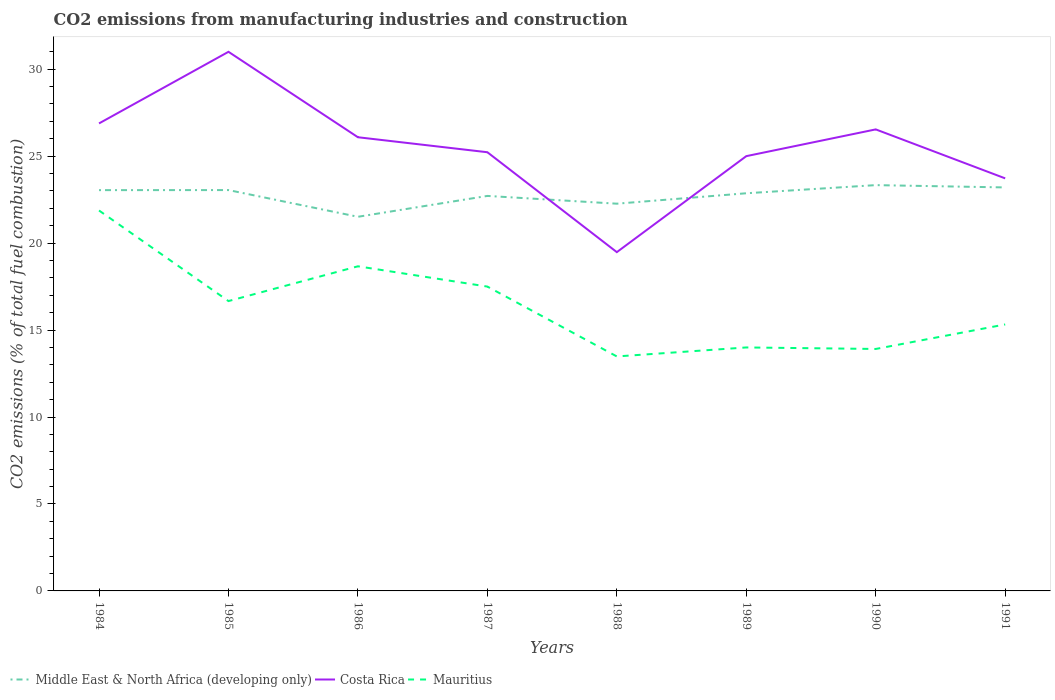Is the number of lines equal to the number of legend labels?
Offer a terse response. Yes. Across all years, what is the maximum amount of CO2 emitted in Middle East & North Africa (developing only)?
Your response must be concise. 21.51. What is the total amount of CO2 emitted in Mauritius in the graph?
Your answer should be compact. 4.75. What is the difference between the highest and the second highest amount of CO2 emitted in Mauritius?
Provide a succinct answer. 8.39. What is the difference between the highest and the lowest amount of CO2 emitted in Middle East & North Africa (developing only)?
Your answer should be very brief. 5. How many years are there in the graph?
Offer a very short reply. 8. What is the difference between two consecutive major ticks on the Y-axis?
Provide a succinct answer. 5. Are the values on the major ticks of Y-axis written in scientific E-notation?
Keep it short and to the point. No. Does the graph contain grids?
Make the answer very short. No. Where does the legend appear in the graph?
Provide a succinct answer. Bottom left. How many legend labels are there?
Give a very brief answer. 3. What is the title of the graph?
Ensure brevity in your answer.  CO2 emissions from manufacturing industries and construction. Does "Colombia" appear as one of the legend labels in the graph?
Your answer should be very brief. No. What is the label or title of the X-axis?
Ensure brevity in your answer.  Years. What is the label or title of the Y-axis?
Offer a very short reply. CO2 emissions (% of total fuel combustion). What is the CO2 emissions (% of total fuel combustion) of Middle East & North Africa (developing only) in 1984?
Offer a terse response. 23.05. What is the CO2 emissions (% of total fuel combustion) in Costa Rica in 1984?
Offer a very short reply. 26.88. What is the CO2 emissions (% of total fuel combustion) in Mauritius in 1984?
Provide a short and direct response. 21.88. What is the CO2 emissions (% of total fuel combustion) of Middle East & North Africa (developing only) in 1985?
Ensure brevity in your answer.  23.05. What is the CO2 emissions (% of total fuel combustion) in Costa Rica in 1985?
Offer a very short reply. 31. What is the CO2 emissions (% of total fuel combustion) in Mauritius in 1985?
Make the answer very short. 16.67. What is the CO2 emissions (% of total fuel combustion) in Middle East & North Africa (developing only) in 1986?
Give a very brief answer. 21.51. What is the CO2 emissions (% of total fuel combustion) in Costa Rica in 1986?
Your answer should be very brief. 26.09. What is the CO2 emissions (% of total fuel combustion) in Mauritius in 1986?
Ensure brevity in your answer.  18.67. What is the CO2 emissions (% of total fuel combustion) of Middle East & North Africa (developing only) in 1987?
Provide a short and direct response. 22.71. What is the CO2 emissions (% of total fuel combustion) in Costa Rica in 1987?
Provide a succinct answer. 25.23. What is the CO2 emissions (% of total fuel combustion) in Middle East & North Africa (developing only) in 1988?
Your response must be concise. 22.27. What is the CO2 emissions (% of total fuel combustion) in Costa Rica in 1988?
Your answer should be compact. 19.48. What is the CO2 emissions (% of total fuel combustion) in Mauritius in 1988?
Offer a very short reply. 13.48. What is the CO2 emissions (% of total fuel combustion) in Middle East & North Africa (developing only) in 1989?
Offer a very short reply. 22.87. What is the CO2 emissions (% of total fuel combustion) in Costa Rica in 1989?
Your answer should be very brief. 25. What is the CO2 emissions (% of total fuel combustion) in Mauritius in 1989?
Provide a short and direct response. 14. What is the CO2 emissions (% of total fuel combustion) in Middle East & North Africa (developing only) in 1990?
Your response must be concise. 23.33. What is the CO2 emissions (% of total fuel combustion) of Costa Rica in 1990?
Your response must be concise. 26.54. What is the CO2 emissions (% of total fuel combustion) of Mauritius in 1990?
Ensure brevity in your answer.  13.91. What is the CO2 emissions (% of total fuel combustion) in Middle East & North Africa (developing only) in 1991?
Your answer should be compact. 23.2. What is the CO2 emissions (% of total fuel combustion) in Costa Rica in 1991?
Your answer should be very brief. 23.72. What is the CO2 emissions (% of total fuel combustion) in Mauritius in 1991?
Your answer should be compact. 15.32. Across all years, what is the maximum CO2 emissions (% of total fuel combustion) in Middle East & North Africa (developing only)?
Your answer should be compact. 23.33. Across all years, what is the maximum CO2 emissions (% of total fuel combustion) of Mauritius?
Ensure brevity in your answer.  21.88. Across all years, what is the minimum CO2 emissions (% of total fuel combustion) in Middle East & North Africa (developing only)?
Your answer should be very brief. 21.51. Across all years, what is the minimum CO2 emissions (% of total fuel combustion) of Costa Rica?
Your response must be concise. 19.48. Across all years, what is the minimum CO2 emissions (% of total fuel combustion) of Mauritius?
Your answer should be compact. 13.48. What is the total CO2 emissions (% of total fuel combustion) of Middle East & North Africa (developing only) in the graph?
Your answer should be very brief. 181.99. What is the total CO2 emissions (% of total fuel combustion) of Costa Rica in the graph?
Provide a short and direct response. 203.94. What is the total CO2 emissions (% of total fuel combustion) of Mauritius in the graph?
Keep it short and to the point. 131.43. What is the difference between the CO2 emissions (% of total fuel combustion) of Middle East & North Africa (developing only) in 1984 and that in 1985?
Your answer should be compact. -0. What is the difference between the CO2 emissions (% of total fuel combustion) in Costa Rica in 1984 and that in 1985?
Keep it short and to the point. -4.12. What is the difference between the CO2 emissions (% of total fuel combustion) in Mauritius in 1984 and that in 1985?
Give a very brief answer. 5.21. What is the difference between the CO2 emissions (% of total fuel combustion) in Middle East & North Africa (developing only) in 1984 and that in 1986?
Ensure brevity in your answer.  1.53. What is the difference between the CO2 emissions (% of total fuel combustion) of Costa Rica in 1984 and that in 1986?
Keep it short and to the point. 0.79. What is the difference between the CO2 emissions (% of total fuel combustion) of Mauritius in 1984 and that in 1986?
Your answer should be compact. 3.21. What is the difference between the CO2 emissions (% of total fuel combustion) of Middle East & North Africa (developing only) in 1984 and that in 1987?
Your answer should be very brief. 0.33. What is the difference between the CO2 emissions (% of total fuel combustion) of Costa Rica in 1984 and that in 1987?
Provide a succinct answer. 1.66. What is the difference between the CO2 emissions (% of total fuel combustion) of Mauritius in 1984 and that in 1987?
Offer a very short reply. 4.38. What is the difference between the CO2 emissions (% of total fuel combustion) of Middle East & North Africa (developing only) in 1984 and that in 1988?
Your answer should be compact. 0.78. What is the difference between the CO2 emissions (% of total fuel combustion) in Costa Rica in 1984 and that in 1988?
Give a very brief answer. 7.4. What is the difference between the CO2 emissions (% of total fuel combustion) of Mauritius in 1984 and that in 1988?
Ensure brevity in your answer.  8.39. What is the difference between the CO2 emissions (% of total fuel combustion) of Middle East & North Africa (developing only) in 1984 and that in 1989?
Your response must be concise. 0.18. What is the difference between the CO2 emissions (% of total fuel combustion) in Costa Rica in 1984 and that in 1989?
Your response must be concise. 1.88. What is the difference between the CO2 emissions (% of total fuel combustion) of Mauritius in 1984 and that in 1989?
Offer a very short reply. 7.88. What is the difference between the CO2 emissions (% of total fuel combustion) in Middle East & North Africa (developing only) in 1984 and that in 1990?
Give a very brief answer. -0.29. What is the difference between the CO2 emissions (% of total fuel combustion) of Costa Rica in 1984 and that in 1990?
Ensure brevity in your answer.  0.34. What is the difference between the CO2 emissions (% of total fuel combustion) in Mauritius in 1984 and that in 1990?
Ensure brevity in your answer.  7.96. What is the difference between the CO2 emissions (% of total fuel combustion) of Middle East & North Africa (developing only) in 1984 and that in 1991?
Your response must be concise. -0.16. What is the difference between the CO2 emissions (% of total fuel combustion) in Costa Rica in 1984 and that in 1991?
Provide a succinct answer. 3.16. What is the difference between the CO2 emissions (% of total fuel combustion) of Mauritius in 1984 and that in 1991?
Make the answer very short. 6.55. What is the difference between the CO2 emissions (% of total fuel combustion) in Middle East & North Africa (developing only) in 1985 and that in 1986?
Offer a terse response. 1.54. What is the difference between the CO2 emissions (% of total fuel combustion) in Costa Rica in 1985 and that in 1986?
Your answer should be compact. 4.91. What is the difference between the CO2 emissions (% of total fuel combustion) in Middle East & North Africa (developing only) in 1985 and that in 1987?
Ensure brevity in your answer.  0.34. What is the difference between the CO2 emissions (% of total fuel combustion) in Costa Rica in 1985 and that in 1987?
Ensure brevity in your answer.  5.77. What is the difference between the CO2 emissions (% of total fuel combustion) in Middle East & North Africa (developing only) in 1985 and that in 1988?
Give a very brief answer. 0.78. What is the difference between the CO2 emissions (% of total fuel combustion) in Costa Rica in 1985 and that in 1988?
Your answer should be compact. 11.52. What is the difference between the CO2 emissions (% of total fuel combustion) in Mauritius in 1985 and that in 1988?
Provide a short and direct response. 3.18. What is the difference between the CO2 emissions (% of total fuel combustion) in Middle East & North Africa (developing only) in 1985 and that in 1989?
Ensure brevity in your answer.  0.18. What is the difference between the CO2 emissions (% of total fuel combustion) in Mauritius in 1985 and that in 1989?
Offer a very short reply. 2.67. What is the difference between the CO2 emissions (% of total fuel combustion) in Middle East & North Africa (developing only) in 1985 and that in 1990?
Make the answer very short. -0.28. What is the difference between the CO2 emissions (% of total fuel combustion) of Costa Rica in 1985 and that in 1990?
Offer a terse response. 4.46. What is the difference between the CO2 emissions (% of total fuel combustion) in Mauritius in 1985 and that in 1990?
Offer a terse response. 2.75. What is the difference between the CO2 emissions (% of total fuel combustion) in Middle East & North Africa (developing only) in 1985 and that in 1991?
Provide a short and direct response. -0.15. What is the difference between the CO2 emissions (% of total fuel combustion) in Costa Rica in 1985 and that in 1991?
Make the answer very short. 7.28. What is the difference between the CO2 emissions (% of total fuel combustion) of Mauritius in 1985 and that in 1991?
Your answer should be very brief. 1.34. What is the difference between the CO2 emissions (% of total fuel combustion) of Middle East & North Africa (developing only) in 1986 and that in 1987?
Offer a very short reply. -1.2. What is the difference between the CO2 emissions (% of total fuel combustion) in Costa Rica in 1986 and that in 1987?
Provide a short and direct response. 0.86. What is the difference between the CO2 emissions (% of total fuel combustion) in Mauritius in 1986 and that in 1987?
Ensure brevity in your answer.  1.17. What is the difference between the CO2 emissions (% of total fuel combustion) in Middle East & North Africa (developing only) in 1986 and that in 1988?
Ensure brevity in your answer.  -0.75. What is the difference between the CO2 emissions (% of total fuel combustion) of Costa Rica in 1986 and that in 1988?
Offer a terse response. 6.61. What is the difference between the CO2 emissions (% of total fuel combustion) of Mauritius in 1986 and that in 1988?
Your answer should be compact. 5.18. What is the difference between the CO2 emissions (% of total fuel combustion) of Middle East & North Africa (developing only) in 1986 and that in 1989?
Offer a terse response. -1.35. What is the difference between the CO2 emissions (% of total fuel combustion) in Costa Rica in 1986 and that in 1989?
Your response must be concise. 1.09. What is the difference between the CO2 emissions (% of total fuel combustion) of Mauritius in 1986 and that in 1989?
Give a very brief answer. 4.67. What is the difference between the CO2 emissions (% of total fuel combustion) of Middle East & North Africa (developing only) in 1986 and that in 1990?
Provide a short and direct response. -1.82. What is the difference between the CO2 emissions (% of total fuel combustion) in Costa Rica in 1986 and that in 1990?
Provide a short and direct response. -0.45. What is the difference between the CO2 emissions (% of total fuel combustion) of Mauritius in 1986 and that in 1990?
Make the answer very short. 4.75. What is the difference between the CO2 emissions (% of total fuel combustion) in Middle East & North Africa (developing only) in 1986 and that in 1991?
Your answer should be compact. -1.69. What is the difference between the CO2 emissions (% of total fuel combustion) of Costa Rica in 1986 and that in 1991?
Make the answer very short. 2.36. What is the difference between the CO2 emissions (% of total fuel combustion) in Mauritius in 1986 and that in 1991?
Your answer should be compact. 3.34. What is the difference between the CO2 emissions (% of total fuel combustion) in Middle East & North Africa (developing only) in 1987 and that in 1988?
Your response must be concise. 0.45. What is the difference between the CO2 emissions (% of total fuel combustion) in Costa Rica in 1987 and that in 1988?
Keep it short and to the point. 5.74. What is the difference between the CO2 emissions (% of total fuel combustion) in Mauritius in 1987 and that in 1988?
Your answer should be very brief. 4.02. What is the difference between the CO2 emissions (% of total fuel combustion) of Middle East & North Africa (developing only) in 1987 and that in 1989?
Ensure brevity in your answer.  -0.15. What is the difference between the CO2 emissions (% of total fuel combustion) in Costa Rica in 1987 and that in 1989?
Offer a very short reply. 0.23. What is the difference between the CO2 emissions (% of total fuel combustion) in Mauritius in 1987 and that in 1989?
Your answer should be very brief. 3.5. What is the difference between the CO2 emissions (% of total fuel combustion) in Middle East & North Africa (developing only) in 1987 and that in 1990?
Give a very brief answer. -0.62. What is the difference between the CO2 emissions (% of total fuel combustion) in Costa Rica in 1987 and that in 1990?
Offer a very short reply. -1.31. What is the difference between the CO2 emissions (% of total fuel combustion) of Mauritius in 1987 and that in 1990?
Ensure brevity in your answer.  3.59. What is the difference between the CO2 emissions (% of total fuel combustion) in Middle East & North Africa (developing only) in 1987 and that in 1991?
Your answer should be compact. -0.49. What is the difference between the CO2 emissions (% of total fuel combustion) in Costa Rica in 1987 and that in 1991?
Keep it short and to the point. 1.5. What is the difference between the CO2 emissions (% of total fuel combustion) of Mauritius in 1987 and that in 1991?
Give a very brief answer. 2.18. What is the difference between the CO2 emissions (% of total fuel combustion) in Middle East & North Africa (developing only) in 1988 and that in 1989?
Give a very brief answer. -0.6. What is the difference between the CO2 emissions (% of total fuel combustion) of Costa Rica in 1988 and that in 1989?
Provide a short and direct response. -5.52. What is the difference between the CO2 emissions (% of total fuel combustion) of Mauritius in 1988 and that in 1989?
Make the answer very short. -0.52. What is the difference between the CO2 emissions (% of total fuel combustion) of Middle East & North Africa (developing only) in 1988 and that in 1990?
Offer a terse response. -1.07. What is the difference between the CO2 emissions (% of total fuel combustion) of Costa Rica in 1988 and that in 1990?
Ensure brevity in your answer.  -7.06. What is the difference between the CO2 emissions (% of total fuel combustion) in Mauritius in 1988 and that in 1990?
Offer a terse response. -0.43. What is the difference between the CO2 emissions (% of total fuel combustion) in Middle East & North Africa (developing only) in 1988 and that in 1991?
Make the answer very short. -0.94. What is the difference between the CO2 emissions (% of total fuel combustion) in Costa Rica in 1988 and that in 1991?
Your answer should be very brief. -4.24. What is the difference between the CO2 emissions (% of total fuel combustion) of Mauritius in 1988 and that in 1991?
Give a very brief answer. -1.84. What is the difference between the CO2 emissions (% of total fuel combustion) in Middle East & North Africa (developing only) in 1989 and that in 1990?
Your response must be concise. -0.47. What is the difference between the CO2 emissions (% of total fuel combustion) in Costa Rica in 1989 and that in 1990?
Give a very brief answer. -1.54. What is the difference between the CO2 emissions (% of total fuel combustion) in Mauritius in 1989 and that in 1990?
Make the answer very short. 0.09. What is the difference between the CO2 emissions (% of total fuel combustion) in Middle East & North Africa (developing only) in 1989 and that in 1991?
Your answer should be very brief. -0.34. What is the difference between the CO2 emissions (% of total fuel combustion) of Costa Rica in 1989 and that in 1991?
Your answer should be compact. 1.28. What is the difference between the CO2 emissions (% of total fuel combustion) of Mauritius in 1989 and that in 1991?
Offer a very short reply. -1.32. What is the difference between the CO2 emissions (% of total fuel combustion) of Middle East & North Africa (developing only) in 1990 and that in 1991?
Make the answer very short. 0.13. What is the difference between the CO2 emissions (% of total fuel combustion) of Costa Rica in 1990 and that in 1991?
Your answer should be very brief. 2.82. What is the difference between the CO2 emissions (% of total fuel combustion) in Mauritius in 1990 and that in 1991?
Provide a succinct answer. -1.41. What is the difference between the CO2 emissions (% of total fuel combustion) in Middle East & North Africa (developing only) in 1984 and the CO2 emissions (% of total fuel combustion) in Costa Rica in 1985?
Give a very brief answer. -7.95. What is the difference between the CO2 emissions (% of total fuel combustion) in Middle East & North Africa (developing only) in 1984 and the CO2 emissions (% of total fuel combustion) in Mauritius in 1985?
Offer a terse response. 6.38. What is the difference between the CO2 emissions (% of total fuel combustion) in Costa Rica in 1984 and the CO2 emissions (% of total fuel combustion) in Mauritius in 1985?
Your answer should be compact. 10.22. What is the difference between the CO2 emissions (% of total fuel combustion) in Middle East & North Africa (developing only) in 1984 and the CO2 emissions (% of total fuel combustion) in Costa Rica in 1986?
Your response must be concise. -3.04. What is the difference between the CO2 emissions (% of total fuel combustion) of Middle East & North Africa (developing only) in 1984 and the CO2 emissions (% of total fuel combustion) of Mauritius in 1986?
Your answer should be compact. 4.38. What is the difference between the CO2 emissions (% of total fuel combustion) in Costa Rica in 1984 and the CO2 emissions (% of total fuel combustion) in Mauritius in 1986?
Your answer should be very brief. 8.22. What is the difference between the CO2 emissions (% of total fuel combustion) of Middle East & North Africa (developing only) in 1984 and the CO2 emissions (% of total fuel combustion) of Costa Rica in 1987?
Your response must be concise. -2.18. What is the difference between the CO2 emissions (% of total fuel combustion) in Middle East & North Africa (developing only) in 1984 and the CO2 emissions (% of total fuel combustion) in Mauritius in 1987?
Make the answer very short. 5.55. What is the difference between the CO2 emissions (% of total fuel combustion) in Costa Rica in 1984 and the CO2 emissions (% of total fuel combustion) in Mauritius in 1987?
Provide a succinct answer. 9.38. What is the difference between the CO2 emissions (% of total fuel combustion) in Middle East & North Africa (developing only) in 1984 and the CO2 emissions (% of total fuel combustion) in Costa Rica in 1988?
Keep it short and to the point. 3.57. What is the difference between the CO2 emissions (% of total fuel combustion) of Middle East & North Africa (developing only) in 1984 and the CO2 emissions (% of total fuel combustion) of Mauritius in 1988?
Make the answer very short. 9.56. What is the difference between the CO2 emissions (% of total fuel combustion) of Costa Rica in 1984 and the CO2 emissions (% of total fuel combustion) of Mauritius in 1988?
Ensure brevity in your answer.  13.4. What is the difference between the CO2 emissions (% of total fuel combustion) in Middle East & North Africa (developing only) in 1984 and the CO2 emissions (% of total fuel combustion) in Costa Rica in 1989?
Provide a succinct answer. -1.95. What is the difference between the CO2 emissions (% of total fuel combustion) of Middle East & North Africa (developing only) in 1984 and the CO2 emissions (% of total fuel combustion) of Mauritius in 1989?
Your answer should be compact. 9.05. What is the difference between the CO2 emissions (% of total fuel combustion) of Costa Rica in 1984 and the CO2 emissions (% of total fuel combustion) of Mauritius in 1989?
Make the answer very short. 12.88. What is the difference between the CO2 emissions (% of total fuel combustion) in Middle East & North Africa (developing only) in 1984 and the CO2 emissions (% of total fuel combustion) in Costa Rica in 1990?
Offer a terse response. -3.49. What is the difference between the CO2 emissions (% of total fuel combustion) of Middle East & North Africa (developing only) in 1984 and the CO2 emissions (% of total fuel combustion) of Mauritius in 1990?
Your response must be concise. 9.13. What is the difference between the CO2 emissions (% of total fuel combustion) in Costa Rica in 1984 and the CO2 emissions (% of total fuel combustion) in Mauritius in 1990?
Keep it short and to the point. 12.97. What is the difference between the CO2 emissions (% of total fuel combustion) in Middle East & North Africa (developing only) in 1984 and the CO2 emissions (% of total fuel combustion) in Costa Rica in 1991?
Offer a very short reply. -0.68. What is the difference between the CO2 emissions (% of total fuel combustion) of Middle East & North Africa (developing only) in 1984 and the CO2 emissions (% of total fuel combustion) of Mauritius in 1991?
Offer a very short reply. 7.72. What is the difference between the CO2 emissions (% of total fuel combustion) in Costa Rica in 1984 and the CO2 emissions (% of total fuel combustion) in Mauritius in 1991?
Keep it short and to the point. 11.56. What is the difference between the CO2 emissions (% of total fuel combustion) of Middle East & North Africa (developing only) in 1985 and the CO2 emissions (% of total fuel combustion) of Costa Rica in 1986?
Give a very brief answer. -3.04. What is the difference between the CO2 emissions (% of total fuel combustion) in Middle East & North Africa (developing only) in 1985 and the CO2 emissions (% of total fuel combustion) in Mauritius in 1986?
Make the answer very short. 4.38. What is the difference between the CO2 emissions (% of total fuel combustion) in Costa Rica in 1985 and the CO2 emissions (% of total fuel combustion) in Mauritius in 1986?
Make the answer very short. 12.33. What is the difference between the CO2 emissions (% of total fuel combustion) in Middle East & North Africa (developing only) in 1985 and the CO2 emissions (% of total fuel combustion) in Costa Rica in 1987?
Give a very brief answer. -2.18. What is the difference between the CO2 emissions (% of total fuel combustion) of Middle East & North Africa (developing only) in 1985 and the CO2 emissions (% of total fuel combustion) of Mauritius in 1987?
Offer a terse response. 5.55. What is the difference between the CO2 emissions (% of total fuel combustion) of Middle East & North Africa (developing only) in 1985 and the CO2 emissions (% of total fuel combustion) of Costa Rica in 1988?
Offer a terse response. 3.57. What is the difference between the CO2 emissions (% of total fuel combustion) in Middle East & North Africa (developing only) in 1985 and the CO2 emissions (% of total fuel combustion) in Mauritius in 1988?
Keep it short and to the point. 9.57. What is the difference between the CO2 emissions (% of total fuel combustion) of Costa Rica in 1985 and the CO2 emissions (% of total fuel combustion) of Mauritius in 1988?
Your answer should be compact. 17.52. What is the difference between the CO2 emissions (% of total fuel combustion) of Middle East & North Africa (developing only) in 1985 and the CO2 emissions (% of total fuel combustion) of Costa Rica in 1989?
Give a very brief answer. -1.95. What is the difference between the CO2 emissions (% of total fuel combustion) of Middle East & North Africa (developing only) in 1985 and the CO2 emissions (% of total fuel combustion) of Mauritius in 1989?
Make the answer very short. 9.05. What is the difference between the CO2 emissions (% of total fuel combustion) in Middle East & North Africa (developing only) in 1985 and the CO2 emissions (% of total fuel combustion) in Costa Rica in 1990?
Provide a short and direct response. -3.49. What is the difference between the CO2 emissions (% of total fuel combustion) in Middle East & North Africa (developing only) in 1985 and the CO2 emissions (% of total fuel combustion) in Mauritius in 1990?
Offer a terse response. 9.14. What is the difference between the CO2 emissions (% of total fuel combustion) in Costa Rica in 1985 and the CO2 emissions (% of total fuel combustion) in Mauritius in 1990?
Your answer should be very brief. 17.09. What is the difference between the CO2 emissions (% of total fuel combustion) of Middle East & North Africa (developing only) in 1985 and the CO2 emissions (% of total fuel combustion) of Costa Rica in 1991?
Keep it short and to the point. -0.67. What is the difference between the CO2 emissions (% of total fuel combustion) in Middle East & North Africa (developing only) in 1985 and the CO2 emissions (% of total fuel combustion) in Mauritius in 1991?
Ensure brevity in your answer.  7.73. What is the difference between the CO2 emissions (% of total fuel combustion) in Costa Rica in 1985 and the CO2 emissions (% of total fuel combustion) in Mauritius in 1991?
Your answer should be compact. 15.68. What is the difference between the CO2 emissions (% of total fuel combustion) in Middle East & North Africa (developing only) in 1986 and the CO2 emissions (% of total fuel combustion) in Costa Rica in 1987?
Offer a very short reply. -3.71. What is the difference between the CO2 emissions (% of total fuel combustion) of Middle East & North Africa (developing only) in 1986 and the CO2 emissions (% of total fuel combustion) of Mauritius in 1987?
Keep it short and to the point. 4.01. What is the difference between the CO2 emissions (% of total fuel combustion) in Costa Rica in 1986 and the CO2 emissions (% of total fuel combustion) in Mauritius in 1987?
Ensure brevity in your answer.  8.59. What is the difference between the CO2 emissions (% of total fuel combustion) of Middle East & North Africa (developing only) in 1986 and the CO2 emissions (% of total fuel combustion) of Costa Rica in 1988?
Provide a short and direct response. 2.03. What is the difference between the CO2 emissions (% of total fuel combustion) in Middle East & North Africa (developing only) in 1986 and the CO2 emissions (% of total fuel combustion) in Mauritius in 1988?
Ensure brevity in your answer.  8.03. What is the difference between the CO2 emissions (% of total fuel combustion) in Costa Rica in 1986 and the CO2 emissions (% of total fuel combustion) in Mauritius in 1988?
Provide a succinct answer. 12.6. What is the difference between the CO2 emissions (% of total fuel combustion) in Middle East & North Africa (developing only) in 1986 and the CO2 emissions (% of total fuel combustion) in Costa Rica in 1989?
Ensure brevity in your answer.  -3.49. What is the difference between the CO2 emissions (% of total fuel combustion) of Middle East & North Africa (developing only) in 1986 and the CO2 emissions (% of total fuel combustion) of Mauritius in 1989?
Offer a terse response. 7.51. What is the difference between the CO2 emissions (% of total fuel combustion) of Costa Rica in 1986 and the CO2 emissions (% of total fuel combustion) of Mauritius in 1989?
Provide a short and direct response. 12.09. What is the difference between the CO2 emissions (% of total fuel combustion) in Middle East & North Africa (developing only) in 1986 and the CO2 emissions (% of total fuel combustion) in Costa Rica in 1990?
Make the answer very short. -5.02. What is the difference between the CO2 emissions (% of total fuel combustion) of Middle East & North Africa (developing only) in 1986 and the CO2 emissions (% of total fuel combustion) of Mauritius in 1990?
Ensure brevity in your answer.  7.6. What is the difference between the CO2 emissions (% of total fuel combustion) in Costa Rica in 1986 and the CO2 emissions (% of total fuel combustion) in Mauritius in 1990?
Your response must be concise. 12.17. What is the difference between the CO2 emissions (% of total fuel combustion) in Middle East & North Africa (developing only) in 1986 and the CO2 emissions (% of total fuel combustion) in Costa Rica in 1991?
Your answer should be very brief. -2.21. What is the difference between the CO2 emissions (% of total fuel combustion) of Middle East & North Africa (developing only) in 1986 and the CO2 emissions (% of total fuel combustion) of Mauritius in 1991?
Keep it short and to the point. 6.19. What is the difference between the CO2 emissions (% of total fuel combustion) in Costa Rica in 1986 and the CO2 emissions (% of total fuel combustion) in Mauritius in 1991?
Ensure brevity in your answer.  10.76. What is the difference between the CO2 emissions (% of total fuel combustion) of Middle East & North Africa (developing only) in 1987 and the CO2 emissions (% of total fuel combustion) of Costa Rica in 1988?
Provide a short and direct response. 3.23. What is the difference between the CO2 emissions (% of total fuel combustion) in Middle East & North Africa (developing only) in 1987 and the CO2 emissions (% of total fuel combustion) in Mauritius in 1988?
Provide a succinct answer. 9.23. What is the difference between the CO2 emissions (% of total fuel combustion) in Costa Rica in 1987 and the CO2 emissions (% of total fuel combustion) in Mauritius in 1988?
Make the answer very short. 11.74. What is the difference between the CO2 emissions (% of total fuel combustion) in Middle East & North Africa (developing only) in 1987 and the CO2 emissions (% of total fuel combustion) in Costa Rica in 1989?
Keep it short and to the point. -2.29. What is the difference between the CO2 emissions (% of total fuel combustion) in Middle East & North Africa (developing only) in 1987 and the CO2 emissions (% of total fuel combustion) in Mauritius in 1989?
Provide a short and direct response. 8.71. What is the difference between the CO2 emissions (% of total fuel combustion) in Costa Rica in 1987 and the CO2 emissions (% of total fuel combustion) in Mauritius in 1989?
Offer a very short reply. 11.23. What is the difference between the CO2 emissions (% of total fuel combustion) of Middle East & North Africa (developing only) in 1987 and the CO2 emissions (% of total fuel combustion) of Costa Rica in 1990?
Make the answer very short. -3.83. What is the difference between the CO2 emissions (% of total fuel combustion) of Middle East & North Africa (developing only) in 1987 and the CO2 emissions (% of total fuel combustion) of Mauritius in 1990?
Ensure brevity in your answer.  8.8. What is the difference between the CO2 emissions (% of total fuel combustion) in Costa Rica in 1987 and the CO2 emissions (% of total fuel combustion) in Mauritius in 1990?
Keep it short and to the point. 11.31. What is the difference between the CO2 emissions (% of total fuel combustion) of Middle East & North Africa (developing only) in 1987 and the CO2 emissions (% of total fuel combustion) of Costa Rica in 1991?
Keep it short and to the point. -1.01. What is the difference between the CO2 emissions (% of total fuel combustion) of Middle East & North Africa (developing only) in 1987 and the CO2 emissions (% of total fuel combustion) of Mauritius in 1991?
Your answer should be compact. 7.39. What is the difference between the CO2 emissions (% of total fuel combustion) in Costa Rica in 1987 and the CO2 emissions (% of total fuel combustion) in Mauritius in 1991?
Ensure brevity in your answer.  9.9. What is the difference between the CO2 emissions (% of total fuel combustion) in Middle East & North Africa (developing only) in 1988 and the CO2 emissions (% of total fuel combustion) in Costa Rica in 1989?
Your answer should be compact. -2.73. What is the difference between the CO2 emissions (% of total fuel combustion) of Middle East & North Africa (developing only) in 1988 and the CO2 emissions (% of total fuel combustion) of Mauritius in 1989?
Keep it short and to the point. 8.27. What is the difference between the CO2 emissions (% of total fuel combustion) of Costa Rica in 1988 and the CO2 emissions (% of total fuel combustion) of Mauritius in 1989?
Offer a very short reply. 5.48. What is the difference between the CO2 emissions (% of total fuel combustion) of Middle East & North Africa (developing only) in 1988 and the CO2 emissions (% of total fuel combustion) of Costa Rica in 1990?
Your answer should be compact. -4.27. What is the difference between the CO2 emissions (% of total fuel combustion) of Middle East & North Africa (developing only) in 1988 and the CO2 emissions (% of total fuel combustion) of Mauritius in 1990?
Your response must be concise. 8.35. What is the difference between the CO2 emissions (% of total fuel combustion) of Costa Rica in 1988 and the CO2 emissions (% of total fuel combustion) of Mauritius in 1990?
Make the answer very short. 5.57. What is the difference between the CO2 emissions (% of total fuel combustion) of Middle East & North Africa (developing only) in 1988 and the CO2 emissions (% of total fuel combustion) of Costa Rica in 1991?
Give a very brief answer. -1.46. What is the difference between the CO2 emissions (% of total fuel combustion) in Middle East & North Africa (developing only) in 1988 and the CO2 emissions (% of total fuel combustion) in Mauritius in 1991?
Ensure brevity in your answer.  6.94. What is the difference between the CO2 emissions (% of total fuel combustion) in Costa Rica in 1988 and the CO2 emissions (% of total fuel combustion) in Mauritius in 1991?
Give a very brief answer. 4.16. What is the difference between the CO2 emissions (% of total fuel combustion) in Middle East & North Africa (developing only) in 1989 and the CO2 emissions (% of total fuel combustion) in Costa Rica in 1990?
Offer a very short reply. -3.67. What is the difference between the CO2 emissions (% of total fuel combustion) of Middle East & North Africa (developing only) in 1989 and the CO2 emissions (% of total fuel combustion) of Mauritius in 1990?
Provide a short and direct response. 8.95. What is the difference between the CO2 emissions (% of total fuel combustion) of Costa Rica in 1989 and the CO2 emissions (% of total fuel combustion) of Mauritius in 1990?
Make the answer very short. 11.09. What is the difference between the CO2 emissions (% of total fuel combustion) of Middle East & North Africa (developing only) in 1989 and the CO2 emissions (% of total fuel combustion) of Costa Rica in 1991?
Offer a very short reply. -0.86. What is the difference between the CO2 emissions (% of total fuel combustion) of Middle East & North Africa (developing only) in 1989 and the CO2 emissions (% of total fuel combustion) of Mauritius in 1991?
Provide a succinct answer. 7.54. What is the difference between the CO2 emissions (% of total fuel combustion) in Costa Rica in 1989 and the CO2 emissions (% of total fuel combustion) in Mauritius in 1991?
Provide a succinct answer. 9.68. What is the difference between the CO2 emissions (% of total fuel combustion) of Middle East & North Africa (developing only) in 1990 and the CO2 emissions (% of total fuel combustion) of Costa Rica in 1991?
Keep it short and to the point. -0.39. What is the difference between the CO2 emissions (% of total fuel combustion) of Middle East & North Africa (developing only) in 1990 and the CO2 emissions (% of total fuel combustion) of Mauritius in 1991?
Provide a short and direct response. 8.01. What is the difference between the CO2 emissions (% of total fuel combustion) of Costa Rica in 1990 and the CO2 emissions (% of total fuel combustion) of Mauritius in 1991?
Give a very brief answer. 11.22. What is the average CO2 emissions (% of total fuel combustion) of Middle East & North Africa (developing only) per year?
Your answer should be compact. 22.75. What is the average CO2 emissions (% of total fuel combustion) in Costa Rica per year?
Your answer should be compact. 25.49. What is the average CO2 emissions (% of total fuel combustion) in Mauritius per year?
Your response must be concise. 16.43. In the year 1984, what is the difference between the CO2 emissions (% of total fuel combustion) of Middle East & North Africa (developing only) and CO2 emissions (% of total fuel combustion) of Costa Rica?
Provide a short and direct response. -3.84. In the year 1984, what is the difference between the CO2 emissions (% of total fuel combustion) of Middle East & North Africa (developing only) and CO2 emissions (% of total fuel combustion) of Mauritius?
Make the answer very short. 1.17. In the year 1984, what is the difference between the CO2 emissions (% of total fuel combustion) in Costa Rica and CO2 emissions (% of total fuel combustion) in Mauritius?
Provide a short and direct response. 5.01. In the year 1985, what is the difference between the CO2 emissions (% of total fuel combustion) in Middle East & North Africa (developing only) and CO2 emissions (% of total fuel combustion) in Costa Rica?
Your answer should be very brief. -7.95. In the year 1985, what is the difference between the CO2 emissions (% of total fuel combustion) of Middle East & North Africa (developing only) and CO2 emissions (% of total fuel combustion) of Mauritius?
Keep it short and to the point. 6.38. In the year 1985, what is the difference between the CO2 emissions (% of total fuel combustion) of Costa Rica and CO2 emissions (% of total fuel combustion) of Mauritius?
Give a very brief answer. 14.33. In the year 1986, what is the difference between the CO2 emissions (% of total fuel combustion) of Middle East & North Africa (developing only) and CO2 emissions (% of total fuel combustion) of Costa Rica?
Make the answer very short. -4.57. In the year 1986, what is the difference between the CO2 emissions (% of total fuel combustion) of Middle East & North Africa (developing only) and CO2 emissions (% of total fuel combustion) of Mauritius?
Your answer should be very brief. 2.85. In the year 1986, what is the difference between the CO2 emissions (% of total fuel combustion) in Costa Rica and CO2 emissions (% of total fuel combustion) in Mauritius?
Make the answer very short. 7.42. In the year 1987, what is the difference between the CO2 emissions (% of total fuel combustion) in Middle East & North Africa (developing only) and CO2 emissions (% of total fuel combustion) in Costa Rica?
Offer a terse response. -2.51. In the year 1987, what is the difference between the CO2 emissions (% of total fuel combustion) in Middle East & North Africa (developing only) and CO2 emissions (% of total fuel combustion) in Mauritius?
Offer a terse response. 5.21. In the year 1987, what is the difference between the CO2 emissions (% of total fuel combustion) in Costa Rica and CO2 emissions (% of total fuel combustion) in Mauritius?
Offer a very short reply. 7.73. In the year 1988, what is the difference between the CO2 emissions (% of total fuel combustion) of Middle East & North Africa (developing only) and CO2 emissions (% of total fuel combustion) of Costa Rica?
Your response must be concise. 2.79. In the year 1988, what is the difference between the CO2 emissions (% of total fuel combustion) of Middle East & North Africa (developing only) and CO2 emissions (% of total fuel combustion) of Mauritius?
Offer a terse response. 8.78. In the year 1988, what is the difference between the CO2 emissions (% of total fuel combustion) in Costa Rica and CO2 emissions (% of total fuel combustion) in Mauritius?
Keep it short and to the point. 6. In the year 1989, what is the difference between the CO2 emissions (% of total fuel combustion) in Middle East & North Africa (developing only) and CO2 emissions (% of total fuel combustion) in Costa Rica?
Keep it short and to the point. -2.13. In the year 1989, what is the difference between the CO2 emissions (% of total fuel combustion) in Middle East & North Africa (developing only) and CO2 emissions (% of total fuel combustion) in Mauritius?
Ensure brevity in your answer.  8.87. In the year 1990, what is the difference between the CO2 emissions (% of total fuel combustion) of Middle East & North Africa (developing only) and CO2 emissions (% of total fuel combustion) of Costa Rica?
Provide a succinct answer. -3.2. In the year 1990, what is the difference between the CO2 emissions (% of total fuel combustion) of Middle East & North Africa (developing only) and CO2 emissions (% of total fuel combustion) of Mauritius?
Your response must be concise. 9.42. In the year 1990, what is the difference between the CO2 emissions (% of total fuel combustion) of Costa Rica and CO2 emissions (% of total fuel combustion) of Mauritius?
Provide a succinct answer. 12.63. In the year 1991, what is the difference between the CO2 emissions (% of total fuel combustion) in Middle East & North Africa (developing only) and CO2 emissions (% of total fuel combustion) in Costa Rica?
Offer a very short reply. -0.52. In the year 1991, what is the difference between the CO2 emissions (% of total fuel combustion) in Middle East & North Africa (developing only) and CO2 emissions (% of total fuel combustion) in Mauritius?
Provide a succinct answer. 7.88. In the year 1991, what is the difference between the CO2 emissions (% of total fuel combustion) in Costa Rica and CO2 emissions (% of total fuel combustion) in Mauritius?
Offer a terse response. 8.4. What is the ratio of the CO2 emissions (% of total fuel combustion) of Middle East & North Africa (developing only) in 1984 to that in 1985?
Your response must be concise. 1. What is the ratio of the CO2 emissions (% of total fuel combustion) in Costa Rica in 1984 to that in 1985?
Offer a terse response. 0.87. What is the ratio of the CO2 emissions (% of total fuel combustion) in Mauritius in 1984 to that in 1985?
Provide a succinct answer. 1.31. What is the ratio of the CO2 emissions (% of total fuel combustion) in Middle East & North Africa (developing only) in 1984 to that in 1986?
Your answer should be compact. 1.07. What is the ratio of the CO2 emissions (% of total fuel combustion) of Costa Rica in 1984 to that in 1986?
Your response must be concise. 1.03. What is the ratio of the CO2 emissions (% of total fuel combustion) of Mauritius in 1984 to that in 1986?
Provide a succinct answer. 1.17. What is the ratio of the CO2 emissions (% of total fuel combustion) of Middle East & North Africa (developing only) in 1984 to that in 1987?
Provide a short and direct response. 1.01. What is the ratio of the CO2 emissions (% of total fuel combustion) of Costa Rica in 1984 to that in 1987?
Keep it short and to the point. 1.07. What is the ratio of the CO2 emissions (% of total fuel combustion) of Middle East & North Africa (developing only) in 1984 to that in 1988?
Provide a short and direct response. 1.03. What is the ratio of the CO2 emissions (% of total fuel combustion) of Costa Rica in 1984 to that in 1988?
Provide a short and direct response. 1.38. What is the ratio of the CO2 emissions (% of total fuel combustion) of Mauritius in 1984 to that in 1988?
Your response must be concise. 1.62. What is the ratio of the CO2 emissions (% of total fuel combustion) of Middle East & North Africa (developing only) in 1984 to that in 1989?
Ensure brevity in your answer.  1.01. What is the ratio of the CO2 emissions (% of total fuel combustion) in Costa Rica in 1984 to that in 1989?
Offer a terse response. 1.08. What is the ratio of the CO2 emissions (% of total fuel combustion) in Mauritius in 1984 to that in 1989?
Offer a very short reply. 1.56. What is the ratio of the CO2 emissions (% of total fuel combustion) of Middle East & North Africa (developing only) in 1984 to that in 1990?
Your answer should be compact. 0.99. What is the ratio of the CO2 emissions (% of total fuel combustion) in Costa Rica in 1984 to that in 1990?
Your answer should be compact. 1.01. What is the ratio of the CO2 emissions (% of total fuel combustion) in Mauritius in 1984 to that in 1990?
Keep it short and to the point. 1.57. What is the ratio of the CO2 emissions (% of total fuel combustion) in Costa Rica in 1984 to that in 1991?
Your response must be concise. 1.13. What is the ratio of the CO2 emissions (% of total fuel combustion) in Mauritius in 1984 to that in 1991?
Your response must be concise. 1.43. What is the ratio of the CO2 emissions (% of total fuel combustion) in Middle East & North Africa (developing only) in 1985 to that in 1986?
Your answer should be compact. 1.07. What is the ratio of the CO2 emissions (% of total fuel combustion) of Costa Rica in 1985 to that in 1986?
Ensure brevity in your answer.  1.19. What is the ratio of the CO2 emissions (% of total fuel combustion) in Mauritius in 1985 to that in 1986?
Offer a very short reply. 0.89. What is the ratio of the CO2 emissions (% of total fuel combustion) in Middle East & North Africa (developing only) in 1985 to that in 1987?
Ensure brevity in your answer.  1.01. What is the ratio of the CO2 emissions (% of total fuel combustion) in Costa Rica in 1985 to that in 1987?
Provide a short and direct response. 1.23. What is the ratio of the CO2 emissions (% of total fuel combustion) in Middle East & North Africa (developing only) in 1985 to that in 1988?
Offer a terse response. 1.04. What is the ratio of the CO2 emissions (% of total fuel combustion) of Costa Rica in 1985 to that in 1988?
Provide a succinct answer. 1.59. What is the ratio of the CO2 emissions (% of total fuel combustion) in Mauritius in 1985 to that in 1988?
Your answer should be compact. 1.24. What is the ratio of the CO2 emissions (% of total fuel combustion) of Costa Rica in 1985 to that in 1989?
Provide a short and direct response. 1.24. What is the ratio of the CO2 emissions (% of total fuel combustion) of Mauritius in 1985 to that in 1989?
Make the answer very short. 1.19. What is the ratio of the CO2 emissions (% of total fuel combustion) in Costa Rica in 1985 to that in 1990?
Offer a very short reply. 1.17. What is the ratio of the CO2 emissions (% of total fuel combustion) in Mauritius in 1985 to that in 1990?
Your answer should be very brief. 1.2. What is the ratio of the CO2 emissions (% of total fuel combustion) in Middle East & North Africa (developing only) in 1985 to that in 1991?
Offer a terse response. 0.99. What is the ratio of the CO2 emissions (% of total fuel combustion) in Costa Rica in 1985 to that in 1991?
Offer a terse response. 1.31. What is the ratio of the CO2 emissions (% of total fuel combustion) in Mauritius in 1985 to that in 1991?
Provide a succinct answer. 1.09. What is the ratio of the CO2 emissions (% of total fuel combustion) of Middle East & North Africa (developing only) in 1986 to that in 1987?
Keep it short and to the point. 0.95. What is the ratio of the CO2 emissions (% of total fuel combustion) of Costa Rica in 1986 to that in 1987?
Your answer should be compact. 1.03. What is the ratio of the CO2 emissions (% of total fuel combustion) in Mauritius in 1986 to that in 1987?
Offer a very short reply. 1.07. What is the ratio of the CO2 emissions (% of total fuel combustion) of Middle East & North Africa (developing only) in 1986 to that in 1988?
Offer a terse response. 0.97. What is the ratio of the CO2 emissions (% of total fuel combustion) of Costa Rica in 1986 to that in 1988?
Ensure brevity in your answer.  1.34. What is the ratio of the CO2 emissions (% of total fuel combustion) in Mauritius in 1986 to that in 1988?
Provide a succinct answer. 1.38. What is the ratio of the CO2 emissions (% of total fuel combustion) of Middle East & North Africa (developing only) in 1986 to that in 1989?
Offer a very short reply. 0.94. What is the ratio of the CO2 emissions (% of total fuel combustion) of Costa Rica in 1986 to that in 1989?
Provide a succinct answer. 1.04. What is the ratio of the CO2 emissions (% of total fuel combustion) of Middle East & North Africa (developing only) in 1986 to that in 1990?
Your answer should be compact. 0.92. What is the ratio of the CO2 emissions (% of total fuel combustion) of Costa Rica in 1986 to that in 1990?
Make the answer very short. 0.98. What is the ratio of the CO2 emissions (% of total fuel combustion) of Mauritius in 1986 to that in 1990?
Your answer should be compact. 1.34. What is the ratio of the CO2 emissions (% of total fuel combustion) in Middle East & North Africa (developing only) in 1986 to that in 1991?
Ensure brevity in your answer.  0.93. What is the ratio of the CO2 emissions (% of total fuel combustion) in Costa Rica in 1986 to that in 1991?
Your answer should be very brief. 1.1. What is the ratio of the CO2 emissions (% of total fuel combustion) of Mauritius in 1986 to that in 1991?
Your answer should be very brief. 1.22. What is the ratio of the CO2 emissions (% of total fuel combustion) of Middle East & North Africa (developing only) in 1987 to that in 1988?
Offer a very short reply. 1.02. What is the ratio of the CO2 emissions (% of total fuel combustion) of Costa Rica in 1987 to that in 1988?
Offer a terse response. 1.29. What is the ratio of the CO2 emissions (% of total fuel combustion) in Mauritius in 1987 to that in 1988?
Offer a very short reply. 1.3. What is the ratio of the CO2 emissions (% of total fuel combustion) of Mauritius in 1987 to that in 1989?
Your answer should be compact. 1.25. What is the ratio of the CO2 emissions (% of total fuel combustion) of Middle East & North Africa (developing only) in 1987 to that in 1990?
Provide a succinct answer. 0.97. What is the ratio of the CO2 emissions (% of total fuel combustion) in Costa Rica in 1987 to that in 1990?
Your answer should be very brief. 0.95. What is the ratio of the CO2 emissions (% of total fuel combustion) of Mauritius in 1987 to that in 1990?
Your answer should be compact. 1.26. What is the ratio of the CO2 emissions (% of total fuel combustion) in Costa Rica in 1987 to that in 1991?
Make the answer very short. 1.06. What is the ratio of the CO2 emissions (% of total fuel combustion) in Mauritius in 1987 to that in 1991?
Provide a short and direct response. 1.14. What is the ratio of the CO2 emissions (% of total fuel combustion) in Middle East & North Africa (developing only) in 1988 to that in 1989?
Your response must be concise. 0.97. What is the ratio of the CO2 emissions (% of total fuel combustion) of Costa Rica in 1988 to that in 1989?
Make the answer very short. 0.78. What is the ratio of the CO2 emissions (% of total fuel combustion) in Mauritius in 1988 to that in 1989?
Keep it short and to the point. 0.96. What is the ratio of the CO2 emissions (% of total fuel combustion) in Middle East & North Africa (developing only) in 1988 to that in 1990?
Provide a succinct answer. 0.95. What is the ratio of the CO2 emissions (% of total fuel combustion) in Costa Rica in 1988 to that in 1990?
Make the answer very short. 0.73. What is the ratio of the CO2 emissions (% of total fuel combustion) in Mauritius in 1988 to that in 1990?
Your answer should be very brief. 0.97. What is the ratio of the CO2 emissions (% of total fuel combustion) in Middle East & North Africa (developing only) in 1988 to that in 1991?
Offer a very short reply. 0.96. What is the ratio of the CO2 emissions (% of total fuel combustion) in Costa Rica in 1988 to that in 1991?
Provide a short and direct response. 0.82. What is the ratio of the CO2 emissions (% of total fuel combustion) of Mauritius in 1988 to that in 1991?
Give a very brief answer. 0.88. What is the ratio of the CO2 emissions (% of total fuel combustion) in Middle East & North Africa (developing only) in 1989 to that in 1990?
Make the answer very short. 0.98. What is the ratio of the CO2 emissions (% of total fuel combustion) of Costa Rica in 1989 to that in 1990?
Ensure brevity in your answer.  0.94. What is the ratio of the CO2 emissions (% of total fuel combustion) of Middle East & North Africa (developing only) in 1989 to that in 1991?
Offer a terse response. 0.99. What is the ratio of the CO2 emissions (% of total fuel combustion) of Costa Rica in 1989 to that in 1991?
Give a very brief answer. 1.05. What is the ratio of the CO2 emissions (% of total fuel combustion) of Mauritius in 1989 to that in 1991?
Ensure brevity in your answer.  0.91. What is the ratio of the CO2 emissions (% of total fuel combustion) in Middle East & North Africa (developing only) in 1990 to that in 1991?
Your response must be concise. 1.01. What is the ratio of the CO2 emissions (% of total fuel combustion) in Costa Rica in 1990 to that in 1991?
Make the answer very short. 1.12. What is the ratio of the CO2 emissions (% of total fuel combustion) of Mauritius in 1990 to that in 1991?
Offer a very short reply. 0.91. What is the difference between the highest and the second highest CO2 emissions (% of total fuel combustion) of Middle East & North Africa (developing only)?
Offer a very short reply. 0.13. What is the difference between the highest and the second highest CO2 emissions (% of total fuel combustion) in Costa Rica?
Your answer should be very brief. 4.12. What is the difference between the highest and the second highest CO2 emissions (% of total fuel combustion) of Mauritius?
Provide a short and direct response. 3.21. What is the difference between the highest and the lowest CO2 emissions (% of total fuel combustion) of Middle East & North Africa (developing only)?
Your answer should be compact. 1.82. What is the difference between the highest and the lowest CO2 emissions (% of total fuel combustion) in Costa Rica?
Make the answer very short. 11.52. What is the difference between the highest and the lowest CO2 emissions (% of total fuel combustion) in Mauritius?
Your response must be concise. 8.39. 